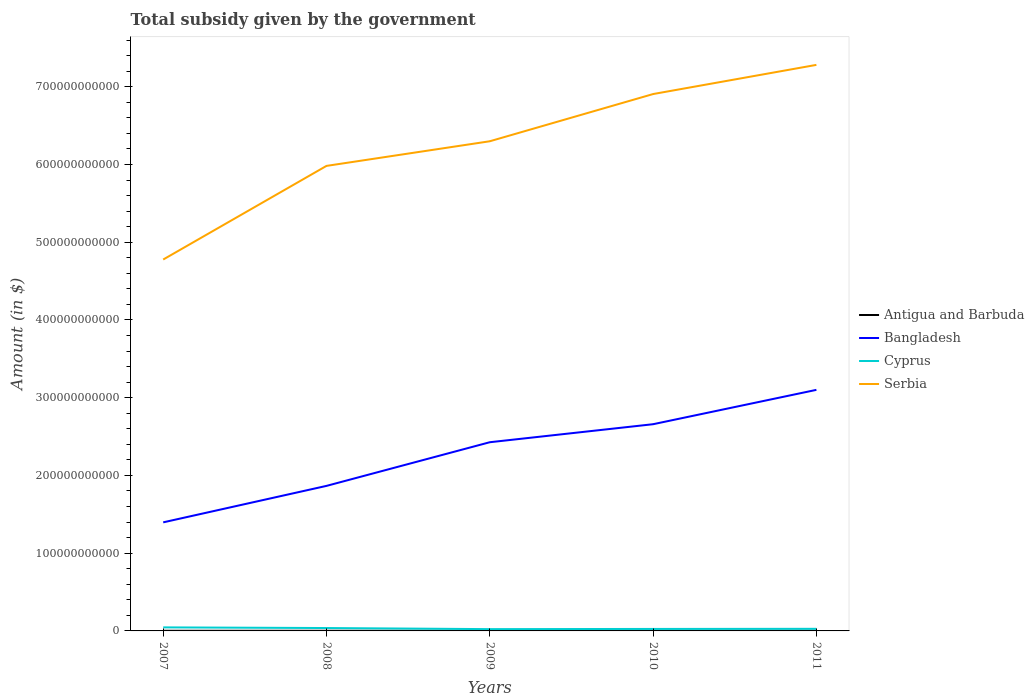How many different coloured lines are there?
Provide a succinct answer. 4. Does the line corresponding to Bangladesh intersect with the line corresponding to Antigua and Barbuda?
Keep it short and to the point. No. Across all years, what is the maximum total revenue collected by the government in Cyprus?
Keep it short and to the point. 2.31e+09. In which year was the total revenue collected by the government in Bangladesh maximum?
Provide a succinct answer. 2007. What is the total total revenue collected by the government in Bangladesh in the graph?
Offer a terse response. -1.24e+11. What is the difference between the highest and the second highest total revenue collected by the government in Cyprus?
Make the answer very short. 2.26e+09. How many lines are there?
Your response must be concise. 4. How many years are there in the graph?
Give a very brief answer. 5. What is the difference between two consecutive major ticks on the Y-axis?
Your answer should be compact. 1.00e+11. Are the values on the major ticks of Y-axis written in scientific E-notation?
Offer a very short reply. No. Does the graph contain any zero values?
Your answer should be very brief. No. Where does the legend appear in the graph?
Offer a terse response. Center right. What is the title of the graph?
Your answer should be compact. Total subsidy given by the government. Does "Guyana" appear as one of the legend labels in the graph?
Ensure brevity in your answer.  No. What is the label or title of the Y-axis?
Offer a very short reply. Amount (in $). What is the Amount (in $) of Antigua and Barbuda in 2007?
Give a very brief answer. 1.88e+08. What is the Amount (in $) of Bangladesh in 2007?
Your answer should be very brief. 1.40e+11. What is the Amount (in $) in Cyprus in 2007?
Offer a very short reply. 4.57e+09. What is the Amount (in $) of Serbia in 2007?
Offer a terse response. 4.78e+11. What is the Amount (in $) of Antigua and Barbuda in 2008?
Ensure brevity in your answer.  1.78e+08. What is the Amount (in $) in Bangladesh in 2008?
Ensure brevity in your answer.  1.87e+11. What is the Amount (in $) of Cyprus in 2008?
Provide a succinct answer. 3.71e+09. What is the Amount (in $) of Serbia in 2008?
Offer a very short reply. 5.98e+11. What is the Amount (in $) of Antigua and Barbuda in 2009?
Your answer should be compact. 2.24e+08. What is the Amount (in $) in Bangladesh in 2009?
Your answer should be compact. 2.43e+11. What is the Amount (in $) of Cyprus in 2009?
Offer a very short reply. 2.31e+09. What is the Amount (in $) of Serbia in 2009?
Offer a very short reply. 6.30e+11. What is the Amount (in $) of Antigua and Barbuda in 2010?
Keep it short and to the point. 2.06e+08. What is the Amount (in $) in Bangladesh in 2010?
Your answer should be compact. 2.66e+11. What is the Amount (in $) in Cyprus in 2010?
Ensure brevity in your answer.  2.56e+09. What is the Amount (in $) in Serbia in 2010?
Give a very brief answer. 6.91e+11. What is the Amount (in $) in Antigua and Barbuda in 2011?
Your response must be concise. 2.48e+08. What is the Amount (in $) in Bangladesh in 2011?
Give a very brief answer. 3.10e+11. What is the Amount (in $) of Cyprus in 2011?
Give a very brief answer. 2.71e+09. What is the Amount (in $) of Serbia in 2011?
Your answer should be very brief. 7.28e+11. Across all years, what is the maximum Amount (in $) in Antigua and Barbuda?
Provide a short and direct response. 2.48e+08. Across all years, what is the maximum Amount (in $) in Bangladesh?
Offer a very short reply. 3.10e+11. Across all years, what is the maximum Amount (in $) of Cyprus?
Offer a very short reply. 4.57e+09. Across all years, what is the maximum Amount (in $) of Serbia?
Provide a short and direct response. 7.28e+11. Across all years, what is the minimum Amount (in $) of Antigua and Barbuda?
Ensure brevity in your answer.  1.78e+08. Across all years, what is the minimum Amount (in $) of Bangladesh?
Keep it short and to the point. 1.40e+11. Across all years, what is the minimum Amount (in $) of Cyprus?
Offer a very short reply. 2.31e+09. Across all years, what is the minimum Amount (in $) in Serbia?
Your answer should be compact. 4.78e+11. What is the total Amount (in $) of Antigua and Barbuda in the graph?
Provide a short and direct response. 1.04e+09. What is the total Amount (in $) in Bangladesh in the graph?
Keep it short and to the point. 1.14e+12. What is the total Amount (in $) of Cyprus in the graph?
Offer a terse response. 1.59e+1. What is the total Amount (in $) in Serbia in the graph?
Your response must be concise. 3.12e+12. What is the difference between the Amount (in $) in Antigua and Barbuda in 2007 and that in 2008?
Keep it short and to the point. 1.01e+07. What is the difference between the Amount (in $) of Bangladesh in 2007 and that in 2008?
Ensure brevity in your answer.  -4.69e+1. What is the difference between the Amount (in $) in Cyprus in 2007 and that in 2008?
Provide a short and direct response. 8.59e+08. What is the difference between the Amount (in $) in Serbia in 2007 and that in 2008?
Your response must be concise. -1.20e+11. What is the difference between the Amount (in $) of Antigua and Barbuda in 2007 and that in 2009?
Provide a short and direct response. -3.59e+07. What is the difference between the Amount (in $) of Bangladesh in 2007 and that in 2009?
Your response must be concise. -1.03e+11. What is the difference between the Amount (in $) in Cyprus in 2007 and that in 2009?
Ensure brevity in your answer.  2.26e+09. What is the difference between the Amount (in $) of Serbia in 2007 and that in 2009?
Provide a succinct answer. -1.52e+11. What is the difference between the Amount (in $) of Antigua and Barbuda in 2007 and that in 2010?
Your answer should be compact. -1.70e+07. What is the difference between the Amount (in $) of Bangladesh in 2007 and that in 2010?
Your answer should be very brief. -1.26e+11. What is the difference between the Amount (in $) of Cyprus in 2007 and that in 2010?
Make the answer very short. 2.01e+09. What is the difference between the Amount (in $) of Serbia in 2007 and that in 2010?
Provide a succinct answer. -2.13e+11. What is the difference between the Amount (in $) of Antigua and Barbuda in 2007 and that in 2011?
Make the answer very short. -5.93e+07. What is the difference between the Amount (in $) of Bangladesh in 2007 and that in 2011?
Offer a very short reply. -1.70e+11. What is the difference between the Amount (in $) of Cyprus in 2007 and that in 2011?
Provide a short and direct response. 1.85e+09. What is the difference between the Amount (in $) of Serbia in 2007 and that in 2011?
Offer a very short reply. -2.50e+11. What is the difference between the Amount (in $) of Antigua and Barbuda in 2008 and that in 2009?
Provide a succinct answer. -4.60e+07. What is the difference between the Amount (in $) in Bangladesh in 2008 and that in 2009?
Keep it short and to the point. -5.62e+1. What is the difference between the Amount (in $) in Cyprus in 2008 and that in 2009?
Give a very brief answer. 1.40e+09. What is the difference between the Amount (in $) of Serbia in 2008 and that in 2009?
Ensure brevity in your answer.  -3.17e+1. What is the difference between the Amount (in $) in Antigua and Barbuda in 2008 and that in 2010?
Your response must be concise. -2.71e+07. What is the difference between the Amount (in $) of Bangladesh in 2008 and that in 2010?
Your answer should be very brief. -7.93e+1. What is the difference between the Amount (in $) in Cyprus in 2008 and that in 2010?
Give a very brief answer. 1.15e+09. What is the difference between the Amount (in $) of Serbia in 2008 and that in 2010?
Your answer should be compact. -9.24e+1. What is the difference between the Amount (in $) of Antigua and Barbuda in 2008 and that in 2011?
Your answer should be very brief. -6.94e+07. What is the difference between the Amount (in $) of Bangladesh in 2008 and that in 2011?
Your answer should be very brief. -1.24e+11. What is the difference between the Amount (in $) of Cyprus in 2008 and that in 2011?
Your answer should be very brief. 9.95e+08. What is the difference between the Amount (in $) in Serbia in 2008 and that in 2011?
Provide a short and direct response. -1.30e+11. What is the difference between the Amount (in $) of Antigua and Barbuda in 2009 and that in 2010?
Your answer should be very brief. 1.89e+07. What is the difference between the Amount (in $) in Bangladesh in 2009 and that in 2010?
Your answer should be compact. -2.32e+1. What is the difference between the Amount (in $) of Cyprus in 2009 and that in 2010?
Provide a succinct answer. -2.53e+08. What is the difference between the Amount (in $) in Serbia in 2009 and that in 2010?
Provide a short and direct response. -6.07e+1. What is the difference between the Amount (in $) of Antigua and Barbuda in 2009 and that in 2011?
Provide a succinct answer. -2.34e+07. What is the difference between the Amount (in $) in Bangladesh in 2009 and that in 2011?
Your answer should be compact. -6.74e+1. What is the difference between the Amount (in $) in Cyprus in 2009 and that in 2011?
Make the answer very short. -4.07e+08. What is the difference between the Amount (in $) of Serbia in 2009 and that in 2011?
Give a very brief answer. -9.83e+1. What is the difference between the Amount (in $) in Antigua and Barbuda in 2010 and that in 2011?
Offer a terse response. -4.23e+07. What is the difference between the Amount (in $) in Bangladesh in 2010 and that in 2011?
Your answer should be compact. -4.42e+1. What is the difference between the Amount (in $) of Cyprus in 2010 and that in 2011?
Provide a succinct answer. -1.53e+08. What is the difference between the Amount (in $) in Serbia in 2010 and that in 2011?
Give a very brief answer. -3.75e+1. What is the difference between the Amount (in $) of Antigua and Barbuda in 2007 and the Amount (in $) of Bangladesh in 2008?
Your answer should be compact. -1.86e+11. What is the difference between the Amount (in $) of Antigua and Barbuda in 2007 and the Amount (in $) of Cyprus in 2008?
Offer a terse response. -3.52e+09. What is the difference between the Amount (in $) in Antigua and Barbuda in 2007 and the Amount (in $) in Serbia in 2008?
Ensure brevity in your answer.  -5.98e+11. What is the difference between the Amount (in $) of Bangladesh in 2007 and the Amount (in $) of Cyprus in 2008?
Keep it short and to the point. 1.36e+11. What is the difference between the Amount (in $) in Bangladesh in 2007 and the Amount (in $) in Serbia in 2008?
Make the answer very short. -4.59e+11. What is the difference between the Amount (in $) in Cyprus in 2007 and the Amount (in $) in Serbia in 2008?
Provide a succinct answer. -5.94e+11. What is the difference between the Amount (in $) of Antigua and Barbuda in 2007 and the Amount (in $) of Bangladesh in 2009?
Make the answer very short. -2.43e+11. What is the difference between the Amount (in $) of Antigua and Barbuda in 2007 and the Amount (in $) of Cyprus in 2009?
Ensure brevity in your answer.  -2.12e+09. What is the difference between the Amount (in $) of Antigua and Barbuda in 2007 and the Amount (in $) of Serbia in 2009?
Your response must be concise. -6.30e+11. What is the difference between the Amount (in $) of Bangladesh in 2007 and the Amount (in $) of Cyprus in 2009?
Offer a terse response. 1.37e+11. What is the difference between the Amount (in $) of Bangladesh in 2007 and the Amount (in $) of Serbia in 2009?
Keep it short and to the point. -4.90e+11. What is the difference between the Amount (in $) in Cyprus in 2007 and the Amount (in $) in Serbia in 2009?
Provide a succinct answer. -6.25e+11. What is the difference between the Amount (in $) in Antigua and Barbuda in 2007 and the Amount (in $) in Bangladesh in 2010?
Ensure brevity in your answer.  -2.66e+11. What is the difference between the Amount (in $) in Antigua and Barbuda in 2007 and the Amount (in $) in Cyprus in 2010?
Provide a succinct answer. -2.37e+09. What is the difference between the Amount (in $) in Antigua and Barbuda in 2007 and the Amount (in $) in Serbia in 2010?
Ensure brevity in your answer.  -6.90e+11. What is the difference between the Amount (in $) in Bangladesh in 2007 and the Amount (in $) in Cyprus in 2010?
Your answer should be very brief. 1.37e+11. What is the difference between the Amount (in $) in Bangladesh in 2007 and the Amount (in $) in Serbia in 2010?
Make the answer very short. -5.51e+11. What is the difference between the Amount (in $) in Cyprus in 2007 and the Amount (in $) in Serbia in 2010?
Ensure brevity in your answer.  -6.86e+11. What is the difference between the Amount (in $) of Antigua and Barbuda in 2007 and the Amount (in $) of Bangladesh in 2011?
Provide a short and direct response. -3.10e+11. What is the difference between the Amount (in $) of Antigua and Barbuda in 2007 and the Amount (in $) of Cyprus in 2011?
Give a very brief answer. -2.53e+09. What is the difference between the Amount (in $) of Antigua and Barbuda in 2007 and the Amount (in $) of Serbia in 2011?
Make the answer very short. -7.28e+11. What is the difference between the Amount (in $) of Bangladesh in 2007 and the Amount (in $) of Cyprus in 2011?
Offer a very short reply. 1.37e+11. What is the difference between the Amount (in $) in Bangladesh in 2007 and the Amount (in $) in Serbia in 2011?
Offer a terse response. -5.88e+11. What is the difference between the Amount (in $) of Cyprus in 2007 and the Amount (in $) of Serbia in 2011?
Provide a short and direct response. -7.24e+11. What is the difference between the Amount (in $) of Antigua and Barbuda in 2008 and the Amount (in $) of Bangladesh in 2009?
Offer a terse response. -2.43e+11. What is the difference between the Amount (in $) in Antigua and Barbuda in 2008 and the Amount (in $) in Cyprus in 2009?
Offer a terse response. -2.13e+09. What is the difference between the Amount (in $) in Antigua and Barbuda in 2008 and the Amount (in $) in Serbia in 2009?
Your answer should be compact. -6.30e+11. What is the difference between the Amount (in $) of Bangladesh in 2008 and the Amount (in $) of Cyprus in 2009?
Offer a terse response. 1.84e+11. What is the difference between the Amount (in $) of Bangladesh in 2008 and the Amount (in $) of Serbia in 2009?
Offer a very short reply. -4.43e+11. What is the difference between the Amount (in $) of Cyprus in 2008 and the Amount (in $) of Serbia in 2009?
Your answer should be compact. -6.26e+11. What is the difference between the Amount (in $) of Antigua and Barbuda in 2008 and the Amount (in $) of Bangladesh in 2010?
Offer a terse response. -2.66e+11. What is the difference between the Amount (in $) of Antigua and Barbuda in 2008 and the Amount (in $) of Cyprus in 2010?
Give a very brief answer. -2.38e+09. What is the difference between the Amount (in $) of Antigua and Barbuda in 2008 and the Amount (in $) of Serbia in 2010?
Give a very brief answer. -6.90e+11. What is the difference between the Amount (in $) of Bangladesh in 2008 and the Amount (in $) of Cyprus in 2010?
Give a very brief answer. 1.84e+11. What is the difference between the Amount (in $) of Bangladesh in 2008 and the Amount (in $) of Serbia in 2010?
Your response must be concise. -5.04e+11. What is the difference between the Amount (in $) in Cyprus in 2008 and the Amount (in $) in Serbia in 2010?
Your answer should be compact. -6.87e+11. What is the difference between the Amount (in $) of Antigua and Barbuda in 2008 and the Amount (in $) of Bangladesh in 2011?
Keep it short and to the point. -3.10e+11. What is the difference between the Amount (in $) in Antigua and Barbuda in 2008 and the Amount (in $) in Cyprus in 2011?
Your response must be concise. -2.54e+09. What is the difference between the Amount (in $) in Antigua and Barbuda in 2008 and the Amount (in $) in Serbia in 2011?
Your answer should be compact. -7.28e+11. What is the difference between the Amount (in $) in Bangladesh in 2008 and the Amount (in $) in Cyprus in 2011?
Ensure brevity in your answer.  1.84e+11. What is the difference between the Amount (in $) in Bangladesh in 2008 and the Amount (in $) in Serbia in 2011?
Keep it short and to the point. -5.42e+11. What is the difference between the Amount (in $) of Cyprus in 2008 and the Amount (in $) of Serbia in 2011?
Provide a succinct answer. -7.24e+11. What is the difference between the Amount (in $) of Antigua and Barbuda in 2009 and the Amount (in $) of Bangladesh in 2010?
Keep it short and to the point. -2.66e+11. What is the difference between the Amount (in $) in Antigua and Barbuda in 2009 and the Amount (in $) in Cyprus in 2010?
Your answer should be very brief. -2.34e+09. What is the difference between the Amount (in $) of Antigua and Barbuda in 2009 and the Amount (in $) of Serbia in 2010?
Provide a short and direct response. -6.90e+11. What is the difference between the Amount (in $) in Bangladesh in 2009 and the Amount (in $) in Cyprus in 2010?
Offer a terse response. 2.40e+11. What is the difference between the Amount (in $) in Bangladesh in 2009 and the Amount (in $) in Serbia in 2010?
Your response must be concise. -4.48e+11. What is the difference between the Amount (in $) of Cyprus in 2009 and the Amount (in $) of Serbia in 2010?
Provide a short and direct response. -6.88e+11. What is the difference between the Amount (in $) in Antigua and Barbuda in 2009 and the Amount (in $) in Bangladesh in 2011?
Give a very brief answer. -3.10e+11. What is the difference between the Amount (in $) in Antigua and Barbuda in 2009 and the Amount (in $) in Cyprus in 2011?
Your response must be concise. -2.49e+09. What is the difference between the Amount (in $) of Antigua and Barbuda in 2009 and the Amount (in $) of Serbia in 2011?
Offer a terse response. -7.28e+11. What is the difference between the Amount (in $) of Bangladesh in 2009 and the Amount (in $) of Cyprus in 2011?
Offer a very short reply. 2.40e+11. What is the difference between the Amount (in $) in Bangladesh in 2009 and the Amount (in $) in Serbia in 2011?
Ensure brevity in your answer.  -4.85e+11. What is the difference between the Amount (in $) in Cyprus in 2009 and the Amount (in $) in Serbia in 2011?
Ensure brevity in your answer.  -7.26e+11. What is the difference between the Amount (in $) of Antigua and Barbuda in 2010 and the Amount (in $) of Bangladesh in 2011?
Keep it short and to the point. -3.10e+11. What is the difference between the Amount (in $) in Antigua and Barbuda in 2010 and the Amount (in $) in Cyprus in 2011?
Your answer should be compact. -2.51e+09. What is the difference between the Amount (in $) in Antigua and Barbuda in 2010 and the Amount (in $) in Serbia in 2011?
Offer a terse response. -7.28e+11. What is the difference between the Amount (in $) in Bangladesh in 2010 and the Amount (in $) in Cyprus in 2011?
Offer a terse response. 2.63e+11. What is the difference between the Amount (in $) of Bangladesh in 2010 and the Amount (in $) of Serbia in 2011?
Your answer should be compact. -4.62e+11. What is the difference between the Amount (in $) in Cyprus in 2010 and the Amount (in $) in Serbia in 2011?
Your answer should be very brief. -7.26e+11. What is the average Amount (in $) in Antigua and Barbuda per year?
Your response must be concise. 2.09e+08. What is the average Amount (in $) of Bangladesh per year?
Your response must be concise. 2.29e+11. What is the average Amount (in $) in Cyprus per year?
Offer a terse response. 3.17e+09. What is the average Amount (in $) of Serbia per year?
Give a very brief answer. 6.25e+11. In the year 2007, what is the difference between the Amount (in $) of Antigua and Barbuda and Amount (in $) of Bangladesh?
Keep it short and to the point. -1.39e+11. In the year 2007, what is the difference between the Amount (in $) of Antigua and Barbuda and Amount (in $) of Cyprus?
Your answer should be compact. -4.38e+09. In the year 2007, what is the difference between the Amount (in $) in Antigua and Barbuda and Amount (in $) in Serbia?
Keep it short and to the point. -4.78e+11. In the year 2007, what is the difference between the Amount (in $) of Bangladesh and Amount (in $) of Cyprus?
Give a very brief answer. 1.35e+11. In the year 2007, what is the difference between the Amount (in $) of Bangladesh and Amount (in $) of Serbia?
Your answer should be very brief. -3.38e+11. In the year 2007, what is the difference between the Amount (in $) in Cyprus and Amount (in $) in Serbia?
Your answer should be very brief. -4.73e+11. In the year 2008, what is the difference between the Amount (in $) of Antigua and Barbuda and Amount (in $) of Bangladesh?
Give a very brief answer. -1.86e+11. In the year 2008, what is the difference between the Amount (in $) of Antigua and Barbuda and Amount (in $) of Cyprus?
Your response must be concise. -3.53e+09. In the year 2008, what is the difference between the Amount (in $) in Antigua and Barbuda and Amount (in $) in Serbia?
Your response must be concise. -5.98e+11. In the year 2008, what is the difference between the Amount (in $) of Bangladesh and Amount (in $) of Cyprus?
Provide a short and direct response. 1.83e+11. In the year 2008, what is the difference between the Amount (in $) in Bangladesh and Amount (in $) in Serbia?
Make the answer very short. -4.12e+11. In the year 2008, what is the difference between the Amount (in $) of Cyprus and Amount (in $) of Serbia?
Offer a very short reply. -5.94e+11. In the year 2009, what is the difference between the Amount (in $) of Antigua and Barbuda and Amount (in $) of Bangladesh?
Give a very brief answer. -2.42e+11. In the year 2009, what is the difference between the Amount (in $) of Antigua and Barbuda and Amount (in $) of Cyprus?
Keep it short and to the point. -2.08e+09. In the year 2009, what is the difference between the Amount (in $) in Antigua and Barbuda and Amount (in $) in Serbia?
Keep it short and to the point. -6.30e+11. In the year 2009, what is the difference between the Amount (in $) of Bangladesh and Amount (in $) of Cyprus?
Provide a short and direct response. 2.40e+11. In the year 2009, what is the difference between the Amount (in $) of Bangladesh and Amount (in $) of Serbia?
Your answer should be compact. -3.87e+11. In the year 2009, what is the difference between the Amount (in $) of Cyprus and Amount (in $) of Serbia?
Your response must be concise. -6.28e+11. In the year 2010, what is the difference between the Amount (in $) in Antigua and Barbuda and Amount (in $) in Bangladesh?
Keep it short and to the point. -2.66e+11. In the year 2010, what is the difference between the Amount (in $) of Antigua and Barbuda and Amount (in $) of Cyprus?
Keep it short and to the point. -2.36e+09. In the year 2010, what is the difference between the Amount (in $) of Antigua and Barbuda and Amount (in $) of Serbia?
Provide a succinct answer. -6.90e+11. In the year 2010, what is the difference between the Amount (in $) of Bangladesh and Amount (in $) of Cyprus?
Offer a very short reply. 2.63e+11. In the year 2010, what is the difference between the Amount (in $) of Bangladesh and Amount (in $) of Serbia?
Keep it short and to the point. -4.25e+11. In the year 2010, what is the difference between the Amount (in $) of Cyprus and Amount (in $) of Serbia?
Your answer should be compact. -6.88e+11. In the year 2011, what is the difference between the Amount (in $) of Antigua and Barbuda and Amount (in $) of Bangladesh?
Give a very brief answer. -3.10e+11. In the year 2011, what is the difference between the Amount (in $) of Antigua and Barbuda and Amount (in $) of Cyprus?
Give a very brief answer. -2.47e+09. In the year 2011, what is the difference between the Amount (in $) of Antigua and Barbuda and Amount (in $) of Serbia?
Provide a succinct answer. -7.28e+11. In the year 2011, what is the difference between the Amount (in $) of Bangladesh and Amount (in $) of Cyprus?
Give a very brief answer. 3.07e+11. In the year 2011, what is the difference between the Amount (in $) of Bangladesh and Amount (in $) of Serbia?
Provide a succinct answer. -4.18e+11. In the year 2011, what is the difference between the Amount (in $) in Cyprus and Amount (in $) in Serbia?
Provide a succinct answer. -7.25e+11. What is the ratio of the Amount (in $) in Antigua and Barbuda in 2007 to that in 2008?
Ensure brevity in your answer.  1.06. What is the ratio of the Amount (in $) in Bangladesh in 2007 to that in 2008?
Offer a very short reply. 0.75. What is the ratio of the Amount (in $) in Cyprus in 2007 to that in 2008?
Provide a short and direct response. 1.23. What is the ratio of the Amount (in $) in Serbia in 2007 to that in 2008?
Offer a terse response. 0.8. What is the ratio of the Amount (in $) of Antigua and Barbuda in 2007 to that in 2009?
Your response must be concise. 0.84. What is the ratio of the Amount (in $) in Bangladesh in 2007 to that in 2009?
Provide a succinct answer. 0.58. What is the ratio of the Amount (in $) in Cyprus in 2007 to that in 2009?
Make the answer very short. 1.98. What is the ratio of the Amount (in $) in Serbia in 2007 to that in 2009?
Keep it short and to the point. 0.76. What is the ratio of the Amount (in $) of Antigua and Barbuda in 2007 to that in 2010?
Make the answer very short. 0.92. What is the ratio of the Amount (in $) in Bangladesh in 2007 to that in 2010?
Offer a very short reply. 0.53. What is the ratio of the Amount (in $) in Cyprus in 2007 to that in 2010?
Make the answer very short. 1.78. What is the ratio of the Amount (in $) of Serbia in 2007 to that in 2010?
Make the answer very short. 0.69. What is the ratio of the Amount (in $) in Antigua and Barbuda in 2007 to that in 2011?
Give a very brief answer. 0.76. What is the ratio of the Amount (in $) of Bangladesh in 2007 to that in 2011?
Provide a succinct answer. 0.45. What is the ratio of the Amount (in $) of Cyprus in 2007 to that in 2011?
Your response must be concise. 1.68. What is the ratio of the Amount (in $) in Serbia in 2007 to that in 2011?
Your answer should be very brief. 0.66. What is the ratio of the Amount (in $) of Antigua and Barbuda in 2008 to that in 2009?
Ensure brevity in your answer.  0.8. What is the ratio of the Amount (in $) in Bangladesh in 2008 to that in 2009?
Your answer should be very brief. 0.77. What is the ratio of the Amount (in $) of Cyprus in 2008 to that in 2009?
Your response must be concise. 1.61. What is the ratio of the Amount (in $) of Serbia in 2008 to that in 2009?
Offer a terse response. 0.95. What is the ratio of the Amount (in $) in Antigua and Barbuda in 2008 to that in 2010?
Your answer should be compact. 0.87. What is the ratio of the Amount (in $) of Bangladesh in 2008 to that in 2010?
Keep it short and to the point. 0.7. What is the ratio of the Amount (in $) of Cyprus in 2008 to that in 2010?
Your answer should be very brief. 1.45. What is the ratio of the Amount (in $) of Serbia in 2008 to that in 2010?
Ensure brevity in your answer.  0.87. What is the ratio of the Amount (in $) of Antigua and Barbuda in 2008 to that in 2011?
Ensure brevity in your answer.  0.72. What is the ratio of the Amount (in $) of Bangladesh in 2008 to that in 2011?
Make the answer very short. 0.6. What is the ratio of the Amount (in $) of Cyprus in 2008 to that in 2011?
Your answer should be compact. 1.37. What is the ratio of the Amount (in $) in Serbia in 2008 to that in 2011?
Keep it short and to the point. 0.82. What is the ratio of the Amount (in $) of Antigua and Barbuda in 2009 to that in 2010?
Offer a very short reply. 1.09. What is the ratio of the Amount (in $) in Bangladesh in 2009 to that in 2010?
Ensure brevity in your answer.  0.91. What is the ratio of the Amount (in $) in Cyprus in 2009 to that in 2010?
Ensure brevity in your answer.  0.9. What is the ratio of the Amount (in $) of Serbia in 2009 to that in 2010?
Offer a terse response. 0.91. What is the ratio of the Amount (in $) of Antigua and Barbuda in 2009 to that in 2011?
Provide a succinct answer. 0.91. What is the ratio of the Amount (in $) of Bangladesh in 2009 to that in 2011?
Provide a succinct answer. 0.78. What is the ratio of the Amount (in $) of Cyprus in 2009 to that in 2011?
Make the answer very short. 0.85. What is the ratio of the Amount (in $) of Serbia in 2009 to that in 2011?
Your answer should be compact. 0.86. What is the ratio of the Amount (in $) in Antigua and Barbuda in 2010 to that in 2011?
Offer a terse response. 0.83. What is the ratio of the Amount (in $) in Bangladesh in 2010 to that in 2011?
Your answer should be compact. 0.86. What is the ratio of the Amount (in $) in Cyprus in 2010 to that in 2011?
Provide a succinct answer. 0.94. What is the ratio of the Amount (in $) in Serbia in 2010 to that in 2011?
Offer a terse response. 0.95. What is the difference between the highest and the second highest Amount (in $) in Antigua and Barbuda?
Your answer should be compact. 2.34e+07. What is the difference between the highest and the second highest Amount (in $) of Bangladesh?
Your answer should be compact. 4.42e+1. What is the difference between the highest and the second highest Amount (in $) in Cyprus?
Your answer should be very brief. 8.59e+08. What is the difference between the highest and the second highest Amount (in $) of Serbia?
Your answer should be compact. 3.75e+1. What is the difference between the highest and the lowest Amount (in $) of Antigua and Barbuda?
Offer a terse response. 6.94e+07. What is the difference between the highest and the lowest Amount (in $) in Bangladesh?
Provide a short and direct response. 1.70e+11. What is the difference between the highest and the lowest Amount (in $) in Cyprus?
Offer a terse response. 2.26e+09. What is the difference between the highest and the lowest Amount (in $) in Serbia?
Offer a very short reply. 2.50e+11. 